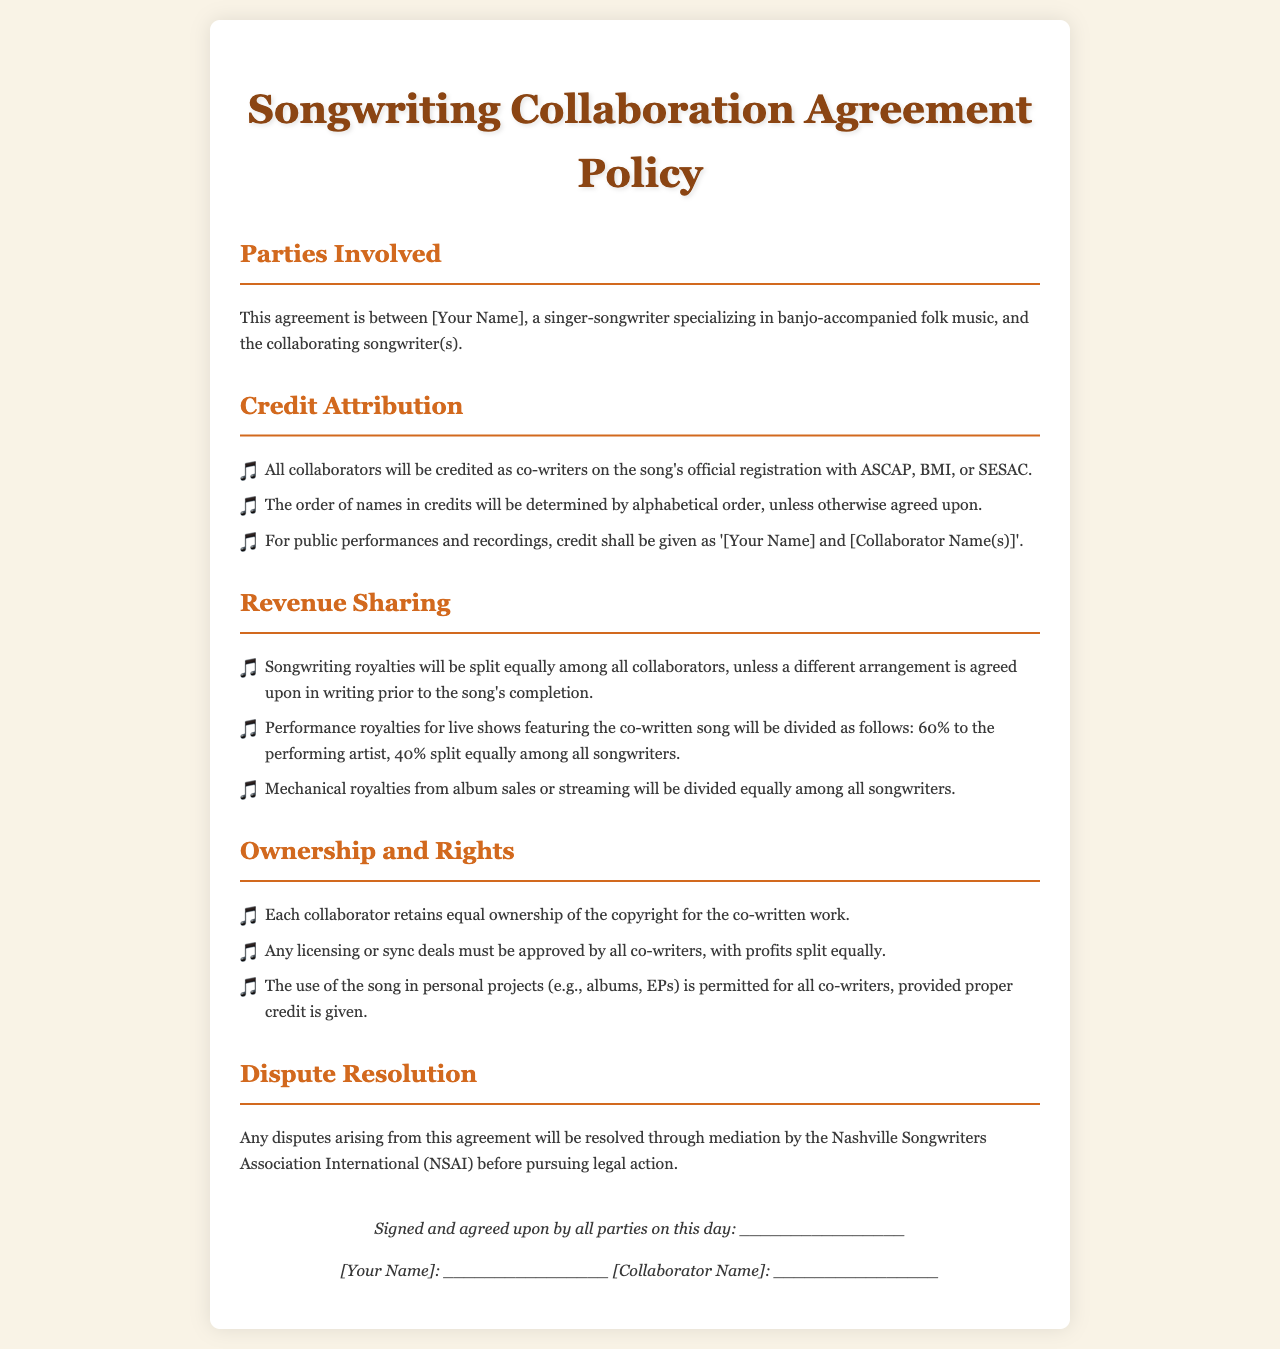What are the parties involved? The parties involved are specified in the introduction of the document as [Your Name] and the collaborating songwriter(s).
Answer: [Your Name] and the collaborating songwriter(s) How are songwriters credited? The document states that all collaborators will be credited as co-writers on song registration and specifies the format for public performances.
Answer: Co-writers What is the revenue sharing for songwriting royalties? The agreement outlines that songwriting royalties will be split equally unless stated otherwise.
Answer: Equally What percentage of performance royalties goes to the performing artist? The document specifies that the performing artist receives 60% of the performance royalties.
Answer: 60% What is required for licensing or sync deals? The document mentions that any licensing or sync deals must be approved by all co-writers.
Answer: Approved by all co-writers How will disputes be resolved? The document outlines that disputes will be resolved through mediation by the Nashville Songwriters Association International (NSAI).
Answer: NSAI In what order are names listed in credits? According to the credit attribution section, names are determined by alphabetical order unless otherwise agreed upon.
Answer: Alphabetical order What must be done for personal projects using the song? The document states that all co-writers can use the song in personal projects provided they give proper credit.
Answer: Proper credit is given 